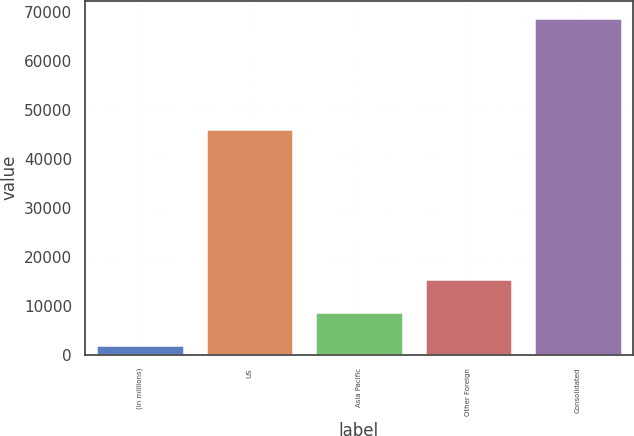Convert chart. <chart><loc_0><loc_0><loc_500><loc_500><bar_chart><fcel>(in millions)<fcel>US<fcel>Asia Pacific<fcel>Other Foreign<fcel>Consolidated<nl><fcel>2013<fcel>46078<fcel>8804<fcel>15490.1<fcel>68874<nl></chart> 